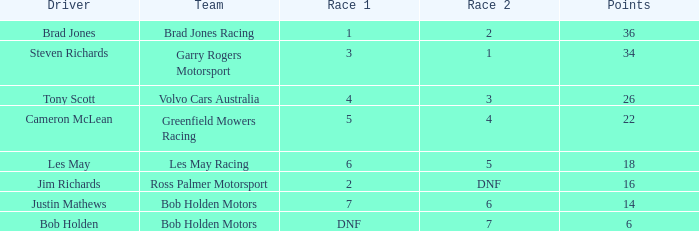Give me the full table as a dictionary. {'header': ['Driver', 'Team', 'Race 1', 'Race 2', 'Points'], 'rows': [['Brad Jones', 'Brad Jones Racing', '1', '2', '36'], ['Steven Richards', 'Garry Rogers Motorsport', '3', '1', '34'], ['Tony Scott', 'Volvo Cars Australia', '4', '3', '26'], ['Cameron McLean', 'Greenfield Mowers Racing', '5', '4', '22'], ['Les May', 'Les May Racing', '6', '5', '18'], ['Jim Richards', 'Ross Palmer Motorsport', '2', 'DNF', '16'], ['Justin Mathews', 'Bob Holden Motors', '7', '6', '14'], ['Bob Holden', 'Bob Holden Motors', 'DNF', '7', '6']]} Which team scored 4 in race 1? Volvo Cars Australia. 